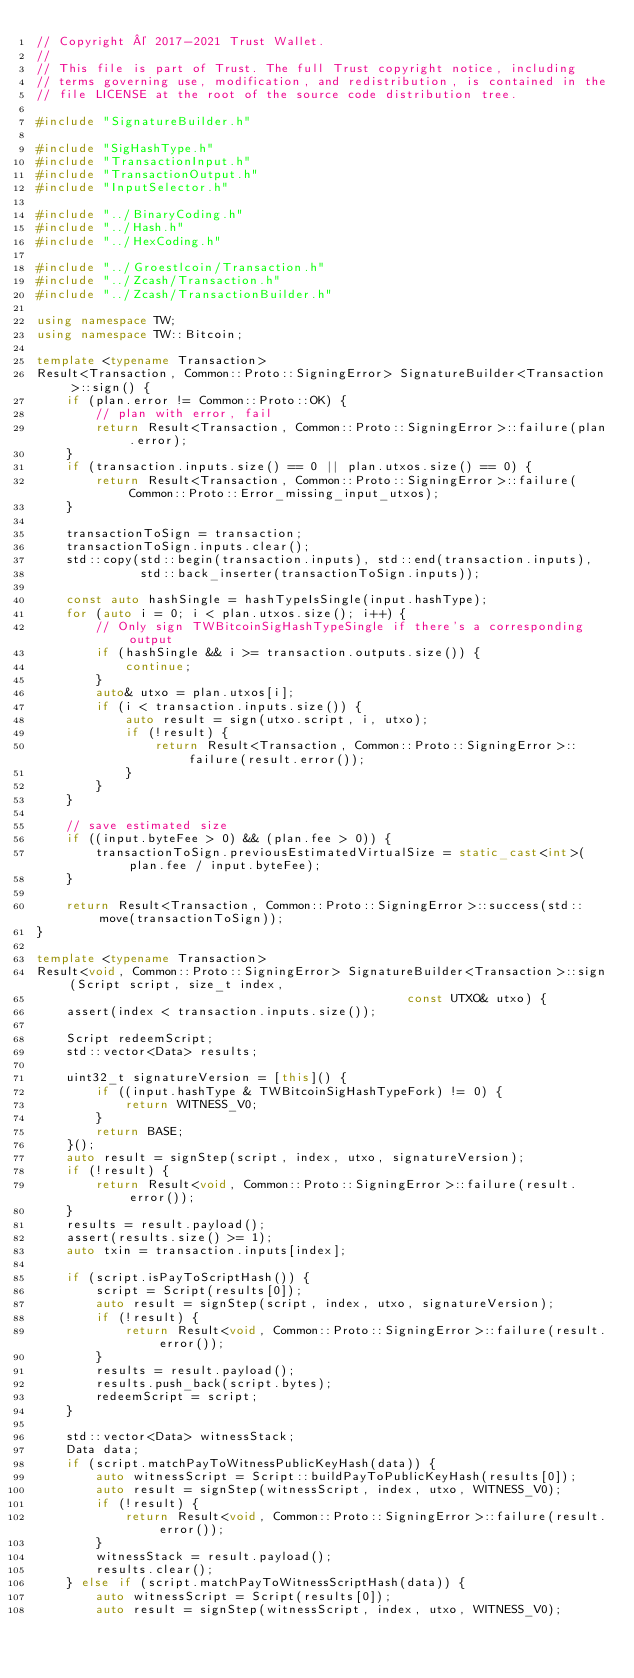Convert code to text. <code><loc_0><loc_0><loc_500><loc_500><_C++_>// Copyright © 2017-2021 Trust Wallet.
//
// This file is part of Trust. The full Trust copyright notice, including
// terms governing use, modification, and redistribution, is contained in the
// file LICENSE at the root of the source code distribution tree.

#include "SignatureBuilder.h"

#include "SigHashType.h"
#include "TransactionInput.h"
#include "TransactionOutput.h"
#include "InputSelector.h"

#include "../BinaryCoding.h"
#include "../Hash.h"
#include "../HexCoding.h"

#include "../Groestlcoin/Transaction.h"
#include "../Zcash/Transaction.h"
#include "../Zcash/TransactionBuilder.h"

using namespace TW;
using namespace TW::Bitcoin;

template <typename Transaction>
Result<Transaction, Common::Proto::SigningError> SignatureBuilder<Transaction>::sign() {
    if (plan.error != Common::Proto::OK) {
        // plan with error, fail
        return Result<Transaction, Common::Proto::SigningError>::failure(plan.error);
    }
    if (transaction.inputs.size() == 0 || plan.utxos.size() == 0) {
        return Result<Transaction, Common::Proto::SigningError>::failure(Common::Proto::Error_missing_input_utxos);
    }

    transactionToSign = transaction;
    transactionToSign.inputs.clear();
    std::copy(std::begin(transaction.inputs), std::end(transaction.inputs),
              std::back_inserter(transactionToSign.inputs));

    const auto hashSingle = hashTypeIsSingle(input.hashType);
    for (auto i = 0; i < plan.utxos.size(); i++) {
        // Only sign TWBitcoinSigHashTypeSingle if there's a corresponding output
        if (hashSingle && i >= transaction.outputs.size()) {
            continue;
        }
        auto& utxo = plan.utxos[i];
        if (i < transaction.inputs.size()) {
            auto result = sign(utxo.script, i, utxo);
            if (!result) {
                return Result<Transaction, Common::Proto::SigningError>::failure(result.error());
            }
        }
    }

    // save estimated size
    if ((input.byteFee > 0) && (plan.fee > 0)) {
        transactionToSign.previousEstimatedVirtualSize = static_cast<int>(plan.fee / input.byteFee);
    }

    return Result<Transaction, Common::Proto::SigningError>::success(std::move(transactionToSign));
}

template <typename Transaction>
Result<void, Common::Proto::SigningError> SignatureBuilder<Transaction>::sign(Script script, size_t index,
                                                  const UTXO& utxo) {
    assert(index < transaction.inputs.size());

    Script redeemScript;
    std::vector<Data> results;

    uint32_t signatureVersion = [this]() {
        if ((input.hashType & TWBitcoinSigHashTypeFork) != 0) {
            return WITNESS_V0;
        } 
        return BASE;
    }();
    auto result = signStep(script, index, utxo, signatureVersion);
    if (!result) {
        return Result<void, Common::Proto::SigningError>::failure(result.error());
    }
    results = result.payload();
    assert(results.size() >= 1);
    auto txin = transaction.inputs[index];

    if (script.isPayToScriptHash()) {
        script = Script(results[0]);
        auto result = signStep(script, index, utxo, signatureVersion);
        if (!result) {
            return Result<void, Common::Proto::SigningError>::failure(result.error());
        }
        results = result.payload();
        results.push_back(script.bytes);
        redeemScript = script;
    }

    std::vector<Data> witnessStack;
    Data data;
    if (script.matchPayToWitnessPublicKeyHash(data)) {
        auto witnessScript = Script::buildPayToPublicKeyHash(results[0]);
        auto result = signStep(witnessScript, index, utxo, WITNESS_V0);
        if (!result) {
            return Result<void, Common::Proto::SigningError>::failure(result.error());
        }
        witnessStack = result.payload();
        results.clear();
    } else if (script.matchPayToWitnessScriptHash(data)) {
        auto witnessScript = Script(results[0]);
        auto result = signStep(witnessScript, index, utxo, WITNESS_V0);</code> 